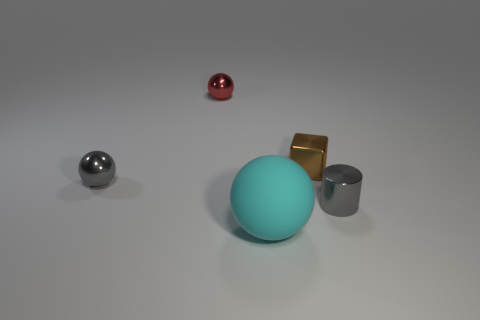Are there any big brown spheres that have the same material as the cyan object? No, there are no big brown spheres in the image. The objects include a large cyan sphere, which appears to have a matte finish, contrasting with the reflective surfaces of the other objects which include a smaller red sphere, a silver sphere, and a couple of cubes. 